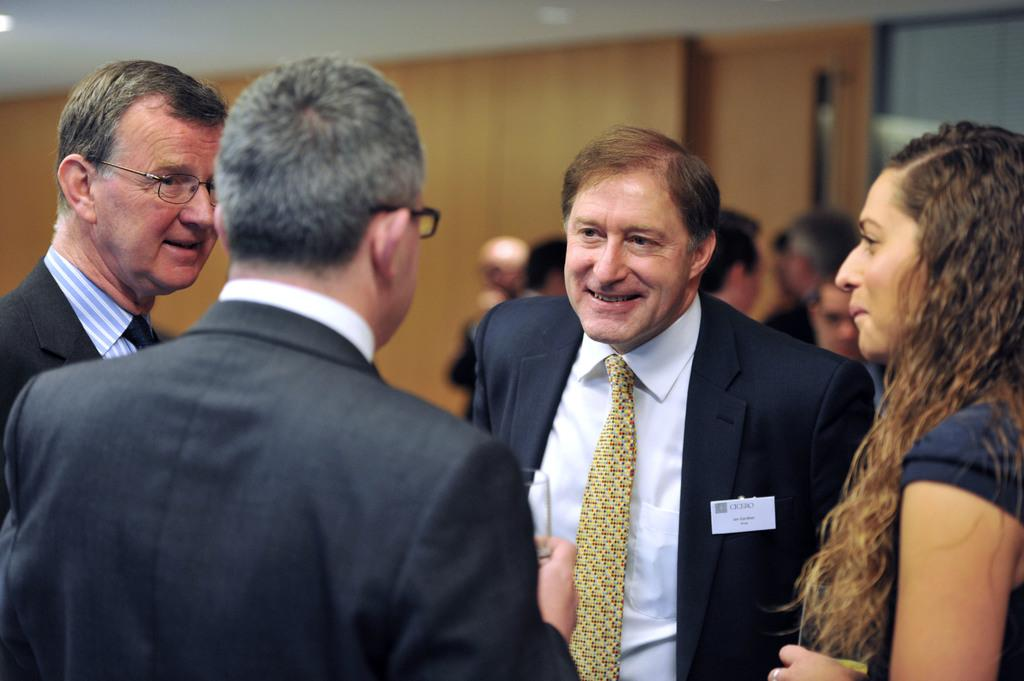What is the main subject of the image? The main subject of the image is groups of people standing. What can be seen in the background of the image? There is a wall in the background of the image. What is visible at the top of the image? The ceiling is visible at the top of the image. What type of arithmetic problem can be solved by the people in the image? There is no indication in the image that the people are solving any arithmetic problems, so it cannot be determined from the picture. 